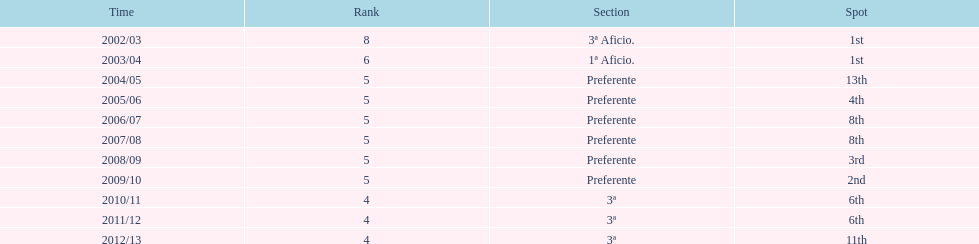Which division placed more than aficio 1a and 3a? Preferente. Write the full table. {'header': ['Time', 'Rank', 'Section', 'Spot'], 'rows': [['2002/03', '8', '3ª Aficio.', '1st'], ['2003/04', '6', '1ª Aficio.', '1st'], ['2004/05', '5', 'Preferente', '13th'], ['2005/06', '5', 'Preferente', '4th'], ['2006/07', '5', 'Preferente', '8th'], ['2007/08', '5', 'Preferente', '8th'], ['2008/09', '5', 'Preferente', '3rd'], ['2009/10', '5', 'Preferente', '2nd'], ['2010/11', '4', '3ª', '6th'], ['2011/12', '4', '3ª', '6th'], ['2012/13', '4', '3ª', '11th']]} 